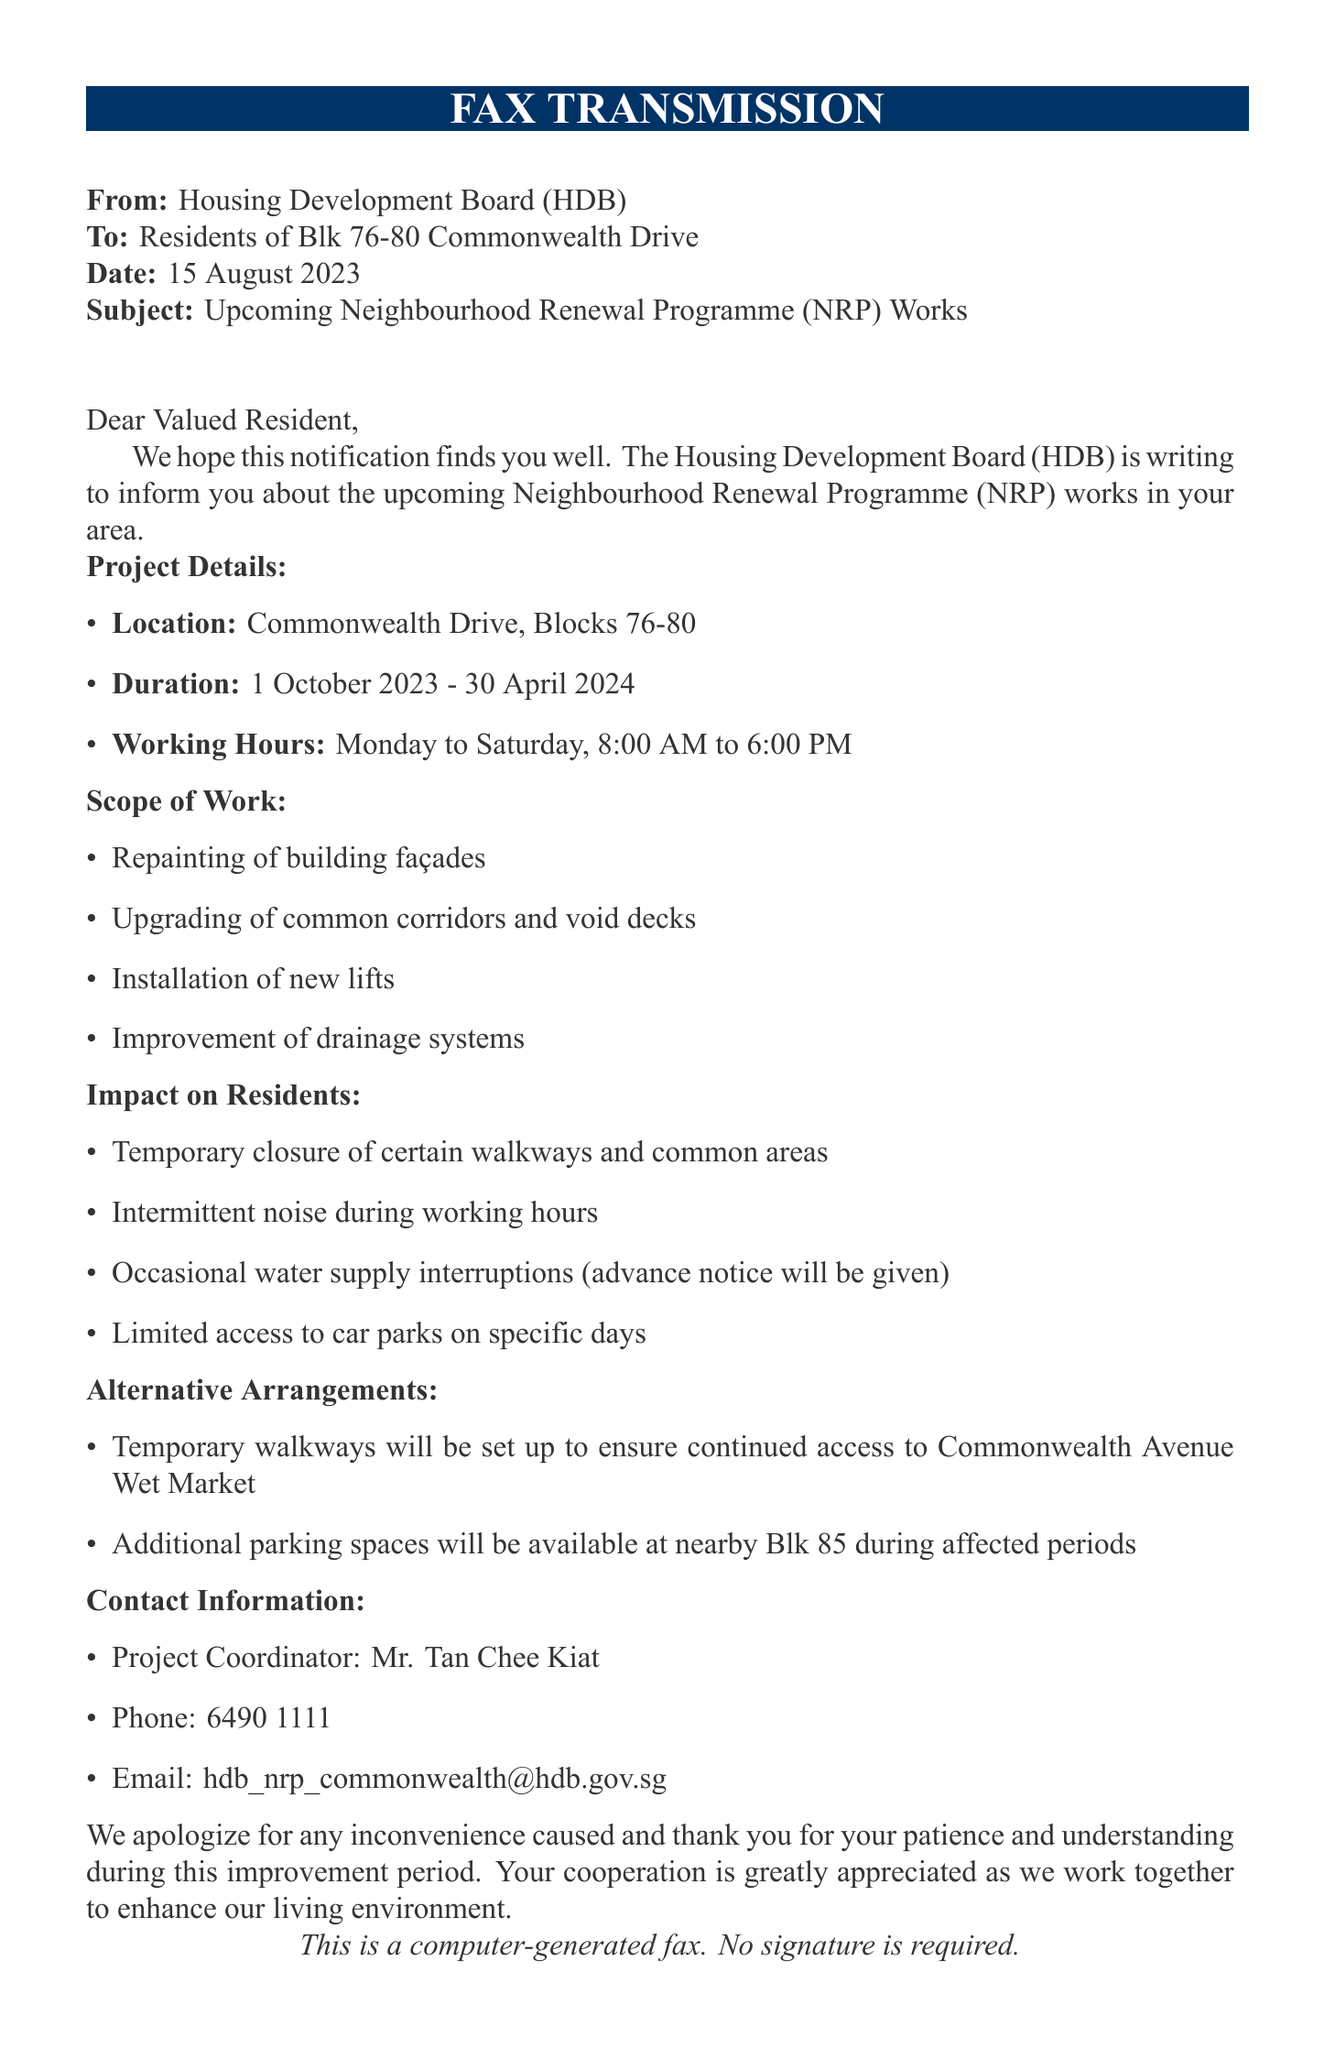What is the project duration? The project duration is clearly stated in the document as spanning from 1 October 2023 to 30 April 2024.
Answer: 1 October 2023 - 30 April 2024 Who is the project coordinator? The document specifies the individual in charge of the project as Mr. Tan Chee Kiat.
Answer: Mr. Tan Chee Kiat What are the working hours for the renovation? The working hours are mentioned in the document as Monday to Saturday, 8:00 AM to 6:00 PM.
Answer: Monday to Saturday, 8:00 AM to 6:00 PM What will be installed during the upgrades? Among the listed scope of work, installation of new lifts is included as part of the renovation.
Answer: New lifts What kind of noise is expected? The document states that there will be intermittent noise during working hours due to the renovations.
Answer: Intermittent noise What alternative arrangements are made for parking? The fax mentions that additional parking spaces will be available at nearby Blk 85 during affected periods.
Answer: Nearby Blk 85 What is the email for contact regarding the project? The document provides the email address for inquiries as hdb_nrp_commonwealth@hdb.gov.sg.
Answer: hdb_nrp_commonwealth@hdb.gov.sg Which blocks are affected by the renovation? The affected blocks are specified in the fax as Blocks 76-80 at Commonwealth Drive.
Answer: Blocks 76-80 